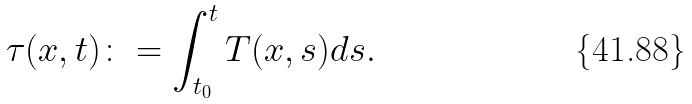<formula> <loc_0><loc_0><loc_500><loc_500>\tau ( x , t ) \colon = \int _ { t _ { 0 } } ^ { t } T ( x , s ) d s .</formula> 